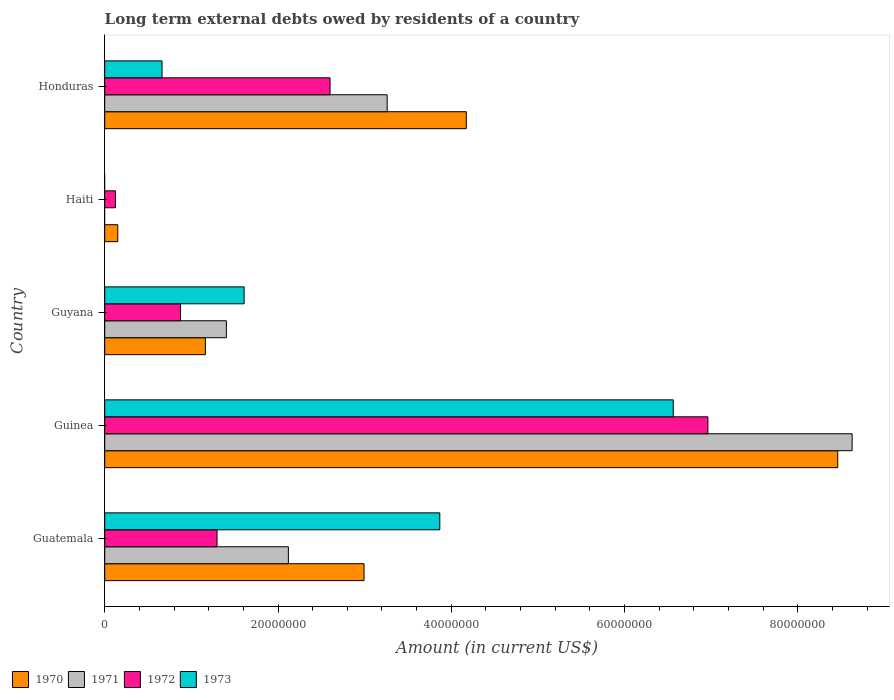How many different coloured bars are there?
Provide a succinct answer. 4. Are the number of bars on each tick of the Y-axis equal?
Your response must be concise. No. What is the label of the 1st group of bars from the top?
Your response must be concise. Honduras. Across all countries, what is the maximum amount of long-term external debts owed by residents in 1971?
Your response must be concise. 8.63e+07. Across all countries, what is the minimum amount of long-term external debts owed by residents in 1972?
Provide a short and direct response. 1.24e+06. In which country was the amount of long-term external debts owed by residents in 1972 maximum?
Offer a very short reply. Guinea. What is the total amount of long-term external debts owed by residents in 1970 in the graph?
Give a very brief answer. 1.69e+08. What is the difference between the amount of long-term external debts owed by residents in 1973 in Guatemala and that in Guyana?
Ensure brevity in your answer.  2.26e+07. What is the difference between the amount of long-term external debts owed by residents in 1970 in Guatemala and the amount of long-term external debts owed by residents in 1973 in Honduras?
Make the answer very short. 2.33e+07. What is the average amount of long-term external debts owed by residents in 1971 per country?
Offer a terse response. 3.08e+07. What is the difference between the amount of long-term external debts owed by residents in 1973 and amount of long-term external debts owed by residents in 1970 in Guatemala?
Offer a very short reply. 8.74e+06. What is the ratio of the amount of long-term external debts owed by residents in 1970 in Guatemala to that in Guyana?
Give a very brief answer. 2.58. Is the amount of long-term external debts owed by residents in 1972 in Haiti less than that in Honduras?
Your response must be concise. Yes. Is the difference between the amount of long-term external debts owed by residents in 1973 in Guatemala and Honduras greater than the difference between the amount of long-term external debts owed by residents in 1970 in Guatemala and Honduras?
Offer a very short reply. Yes. What is the difference between the highest and the second highest amount of long-term external debts owed by residents in 1970?
Provide a succinct answer. 4.29e+07. What is the difference between the highest and the lowest amount of long-term external debts owed by residents in 1972?
Your answer should be compact. 6.84e+07. In how many countries, is the amount of long-term external debts owed by residents in 1970 greater than the average amount of long-term external debts owed by residents in 1970 taken over all countries?
Keep it short and to the point. 2. Is it the case that in every country, the sum of the amount of long-term external debts owed by residents in 1973 and amount of long-term external debts owed by residents in 1970 is greater than the amount of long-term external debts owed by residents in 1971?
Make the answer very short. Yes. How many countries are there in the graph?
Offer a very short reply. 5. What is the difference between two consecutive major ticks on the X-axis?
Keep it short and to the point. 2.00e+07. Does the graph contain any zero values?
Offer a very short reply. Yes. How many legend labels are there?
Make the answer very short. 4. What is the title of the graph?
Keep it short and to the point. Long term external debts owed by residents of a country. Does "1991" appear as one of the legend labels in the graph?
Your answer should be compact. No. What is the label or title of the Y-axis?
Your answer should be compact. Country. What is the Amount (in current US$) in 1970 in Guatemala?
Your answer should be compact. 2.99e+07. What is the Amount (in current US$) in 1971 in Guatemala?
Make the answer very short. 2.12e+07. What is the Amount (in current US$) of 1972 in Guatemala?
Provide a short and direct response. 1.30e+07. What is the Amount (in current US$) in 1973 in Guatemala?
Your response must be concise. 3.87e+07. What is the Amount (in current US$) in 1970 in Guinea?
Your answer should be very brief. 8.46e+07. What is the Amount (in current US$) of 1971 in Guinea?
Your answer should be very brief. 8.63e+07. What is the Amount (in current US$) of 1972 in Guinea?
Offer a terse response. 6.96e+07. What is the Amount (in current US$) of 1973 in Guinea?
Provide a short and direct response. 6.56e+07. What is the Amount (in current US$) in 1970 in Guyana?
Your response must be concise. 1.16e+07. What is the Amount (in current US$) of 1971 in Guyana?
Make the answer very short. 1.40e+07. What is the Amount (in current US$) in 1972 in Guyana?
Provide a short and direct response. 8.75e+06. What is the Amount (in current US$) in 1973 in Guyana?
Provide a succinct answer. 1.61e+07. What is the Amount (in current US$) of 1970 in Haiti?
Give a very brief answer. 1.51e+06. What is the Amount (in current US$) of 1972 in Haiti?
Give a very brief answer. 1.24e+06. What is the Amount (in current US$) in 1973 in Haiti?
Your answer should be compact. 0. What is the Amount (in current US$) in 1970 in Honduras?
Your answer should be very brief. 4.17e+07. What is the Amount (in current US$) in 1971 in Honduras?
Provide a succinct answer. 3.26e+07. What is the Amount (in current US$) of 1972 in Honduras?
Offer a terse response. 2.60e+07. What is the Amount (in current US$) in 1973 in Honduras?
Your answer should be very brief. 6.62e+06. Across all countries, what is the maximum Amount (in current US$) in 1970?
Give a very brief answer. 8.46e+07. Across all countries, what is the maximum Amount (in current US$) of 1971?
Make the answer very short. 8.63e+07. Across all countries, what is the maximum Amount (in current US$) of 1972?
Give a very brief answer. 6.96e+07. Across all countries, what is the maximum Amount (in current US$) of 1973?
Provide a succinct answer. 6.56e+07. Across all countries, what is the minimum Amount (in current US$) in 1970?
Provide a succinct answer. 1.51e+06. Across all countries, what is the minimum Amount (in current US$) of 1972?
Keep it short and to the point. 1.24e+06. What is the total Amount (in current US$) in 1970 in the graph?
Your response must be concise. 1.69e+08. What is the total Amount (in current US$) of 1971 in the graph?
Keep it short and to the point. 1.54e+08. What is the total Amount (in current US$) of 1972 in the graph?
Provide a short and direct response. 1.19e+08. What is the total Amount (in current US$) in 1973 in the graph?
Your answer should be very brief. 1.27e+08. What is the difference between the Amount (in current US$) in 1970 in Guatemala and that in Guinea?
Your response must be concise. -5.47e+07. What is the difference between the Amount (in current US$) in 1971 in Guatemala and that in Guinea?
Provide a short and direct response. -6.51e+07. What is the difference between the Amount (in current US$) of 1972 in Guatemala and that in Guinea?
Your answer should be compact. -5.67e+07. What is the difference between the Amount (in current US$) of 1973 in Guatemala and that in Guinea?
Your response must be concise. -2.69e+07. What is the difference between the Amount (in current US$) in 1970 in Guatemala and that in Guyana?
Offer a terse response. 1.83e+07. What is the difference between the Amount (in current US$) of 1971 in Guatemala and that in Guyana?
Give a very brief answer. 7.16e+06. What is the difference between the Amount (in current US$) of 1972 in Guatemala and that in Guyana?
Offer a terse response. 4.21e+06. What is the difference between the Amount (in current US$) in 1973 in Guatemala and that in Guyana?
Provide a short and direct response. 2.26e+07. What is the difference between the Amount (in current US$) of 1970 in Guatemala and that in Haiti?
Provide a short and direct response. 2.84e+07. What is the difference between the Amount (in current US$) in 1972 in Guatemala and that in Haiti?
Your answer should be compact. 1.17e+07. What is the difference between the Amount (in current US$) in 1970 in Guatemala and that in Honduras?
Make the answer very short. -1.18e+07. What is the difference between the Amount (in current US$) in 1971 in Guatemala and that in Honduras?
Your answer should be compact. -1.14e+07. What is the difference between the Amount (in current US$) of 1972 in Guatemala and that in Honduras?
Give a very brief answer. -1.30e+07. What is the difference between the Amount (in current US$) of 1973 in Guatemala and that in Honduras?
Offer a terse response. 3.21e+07. What is the difference between the Amount (in current US$) in 1970 in Guinea and that in Guyana?
Keep it short and to the point. 7.30e+07. What is the difference between the Amount (in current US$) of 1971 in Guinea and that in Guyana?
Offer a very short reply. 7.22e+07. What is the difference between the Amount (in current US$) of 1972 in Guinea and that in Guyana?
Provide a short and direct response. 6.09e+07. What is the difference between the Amount (in current US$) of 1973 in Guinea and that in Guyana?
Offer a very short reply. 4.95e+07. What is the difference between the Amount (in current US$) of 1970 in Guinea and that in Haiti?
Your answer should be compact. 8.31e+07. What is the difference between the Amount (in current US$) of 1972 in Guinea and that in Haiti?
Ensure brevity in your answer.  6.84e+07. What is the difference between the Amount (in current US$) of 1970 in Guinea and that in Honduras?
Your answer should be compact. 4.29e+07. What is the difference between the Amount (in current US$) of 1971 in Guinea and that in Honduras?
Provide a succinct answer. 5.37e+07. What is the difference between the Amount (in current US$) of 1972 in Guinea and that in Honduras?
Make the answer very short. 4.36e+07. What is the difference between the Amount (in current US$) in 1973 in Guinea and that in Honduras?
Give a very brief answer. 5.90e+07. What is the difference between the Amount (in current US$) in 1970 in Guyana and that in Haiti?
Ensure brevity in your answer.  1.01e+07. What is the difference between the Amount (in current US$) of 1972 in Guyana and that in Haiti?
Offer a very short reply. 7.52e+06. What is the difference between the Amount (in current US$) of 1970 in Guyana and that in Honduras?
Your answer should be very brief. -3.01e+07. What is the difference between the Amount (in current US$) in 1971 in Guyana and that in Honduras?
Give a very brief answer. -1.86e+07. What is the difference between the Amount (in current US$) in 1972 in Guyana and that in Honduras?
Keep it short and to the point. -1.73e+07. What is the difference between the Amount (in current US$) in 1973 in Guyana and that in Honduras?
Your response must be concise. 9.47e+06. What is the difference between the Amount (in current US$) of 1970 in Haiti and that in Honduras?
Give a very brief answer. -4.02e+07. What is the difference between the Amount (in current US$) of 1972 in Haiti and that in Honduras?
Ensure brevity in your answer.  -2.48e+07. What is the difference between the Amount (in current US$) in 1970 in Guatemala and the Amount (in current US$) in 1971 in Guinea?
Keep it short and to the point. -5.63e+07. What is the difference between the Amount (in current US$) of 1970 in Guatemala and the Amount (in current US$) of 1972 in Guinea?
Provide a short and direct response. -3.97e+07. What is the difference between the Amount (in current US$) in 1970 in Guatemala and the Amount (in current US$) in 1973 in Guinea?
Provide a short and direct response. -3.57e+07. What is the difference between the Amount (in current US$) of 1971 in Guatemala and the Amount (in current US$) of 1972 in Guinea?
Make the answer very short. -4.84e+07. What is the difference between the Amount (in current US$) of 1971 in Guatemala and the Amount (in current US$) of 1973 in Guinea?
Keep it short and to the point. -4.44e+07. What is the difference between the Amount (in current US$) in 1972 in Guatemala and the Amount (in current US$) in 1973 in Guinea?
Make the answer very short. -5.27e+07. What is the difference between the Amount (in current US$) of 1970 in Guatemala and the Amount (in current US$) of 1971 in Guyana?
Offer a terse response. 1.59e+07. What is the difference between the Amount (in current US$) of 1970 in Guatemala and the Amount (in current US$) of 1972 in Guyana?
Offer a terse response. 2.12e+07. What is the difference between the Amount (in current US$) of 1970 in Guatemala and the Amount (in current US$) of 1973 in Guyana?
Make the answer very short. 1.38e+07. What is the difference between the Amount (in current US$) in 1971 in Guatemala and the Amount (in current US$) in 1972 in Guyana?
Offer a terse response. 1.24e+07. What is the difference between the Amount (in current US$) of 1971 in Guatemala and the Amount (in current US$) of 1973 in Guyana?
Provide a succinct answer. 5.11e+06. What is the difference between the Amount (in current US$) of 1972 in Guatemala and the Amount (in current US$) of 1973 in Guyana?
Ensure brevity in your answer.  -3.12e+06. What is the difference between the Amount (in current US$) of 1970 in Guatemala and the Amount (in current US$) of 1972 in Haiti?
Keep it short and to the point. 2.87e+07. What is the difference between the Amount (in current US$) in 1971 in Guatemala and the Amount (in current US$) in 1972 in Haiti?
Provide a short and direct response. 2.00e+07. What is the difference between the Amount (in current US$) of 1970 in Guatemala and the Amount (in current US$) of 1971 in Honduras?
Provide a short and direct response. -2.67e+06. What is the difference between the Amount (in current US$) in 1970 in Guatemala and the Amount (in current US$) in 1972 in Honduras?
Give a very brief answer. 3.92e+06. What is the difference between the Amount (in current US$) of 1970 in Guatemala and the Amount (in current US$) of 1973 in Honduras?
Provide a short and direct response. 2.33e+07. What is the difference between the Amount (in current US$) of 1971 in Guatemala and the Amount (in current US$) of 1972 in Honduras?
Give a very brief answer. -4.81e+06. What is the difference between the Amount (in current US$) of 1971 in Guatemala and the Amount (in current US$) of 1973 in Honduras?
Keep it short and to the point. 1.46e+07. What is the difference between the Amount (in current US$) of 1972 in Guatemala and the Amount (in current US$) of 1973 in Honduras?
Your answer should be compact. 6.35e+06. What is the difference between the Amount (in current US$) of 1970 in Guinea and the Amount (in current US$) of 1971 in Guyana?
Offer a very short reply. 7.06e+07. What is the difference between the Amount (in current US$) in 1970 in Guinea and the Amount (in current US$) in 1972 in Guyana?
Offer a terse response. 7.58e+07. What is the difference between the Amount (in current US$) of 1970 in Guinea and the Amount (in current US$) of 1973 in Guyana?
Ensure brevity in your answer.  6.85e+07. What is the difference between the Amount (in current US$) of 1971 in Guinea and the Amount (in current US$) of 1972 in Guyana?
Your answer should be very brief. 7.75e+07. What is the difference between the Amount (in current US$) of 1971 in Guinea and the Amount (in current US$) of 1973 in Guyana?
Make the answer very short. 7.02e+07. What is the difference between the Amount (in current US$) of 1972 in Guinea and the Amount (in current US$) of 1973 in Guyana?
Keep it short and to the point. 5.35e+07. What is the difference between the Amount (in current US$) of 1970 in Guinea and the Amount (in current US$) of 1972 in Haiti?
Offer a terse response. 8.34e+07. What is the difference between the Amount (in current US$) in 1971 in Guinea and the Amount (in current US$) in 1972 in Haiti?
Provide a short and direct response. 8.50e+07. What is the difference between the Amount (in current US$) in 1970 in Guinea and the Amount (in current US$) in 1971 in Honduras?
Keep it short and to the point. 5.20e+07. What is the difference between the Amount (in current US$) of 1970 in Guinea and the Amount (in current US$) of 1972 in Honduras?
Keep it short and to the point. 5.86e+07. What is the difference between the Amount (in current US$) in 1970 in Guinea and the Amount (in current US$) in 1973 in Honduras?
Provide a succinct answer. 7.80e+07. What is the difference between the Amount (in current US$) of 1971 in Guinea and the Amount (in current US$) of 1972 in Honduras?
Keep it short and to the point. 6.03e+07. What is the difference between the Amount (in current US$) of 1971 in Guinea and the Amount (in current US$) of 1973 in Honduras?
Keep it short and to the point. 7.96e+07. What is the difference between the Amount (in current US$) in 1972 in Guinea and the Amount (in current US$) in 1973 in Honduras?
Offer a terse response. 6.30e+07. What is the difference between the Amount (in current US$) of 1970 in Guyana and the Amount (in current US$) of 1972 in Haiti?
Provide a succinct answer. 1.04e+07. What is the difference between the Amount (in current US$) of 1971 in Guyana and the Amount (in current US$) of 1972 in Haiti?
Offer a very short reply. 1.28e+07. What is the difference between the Amount (in current US$) in 1970 in Guyana and the Amount (in current US$) in 1971 in Honduras?
Give a very brief answer. -2.10e+07. What is the difference between the Amount (in current US$) in 1970 in Guyana and the Amount (in current US$) in 1972 in Honduras?
Provide a succinct answer. -1.44e+07. What is the difference between the Amount (in current US$) of 1970 in Guyana and the Amount (in current US$) of 1973 in Honduras?
Provide a short and direct response. 5.00e+06. What is the difference between the Amount (in current US$) in 1971 in Guyana and the Amount (in current US$) in 1972 in Honduras?
Keep it short and to the point. -1.20e+07. What is the difference between the Amount (in current US$) in 1971 in Guyana and the Amount (in current US$) in 1973 in Honduras?
Provide a succinct answer. 7.42e+06. What is the difference between the Amount (in current US$) in 1972 in Guyana and the Amount (in current US$) in 1973 in Honduras?
Your answer should be very brief. 2.14e+06. What is the difference between the Amount (in current US$) in 1970 in Haiti and the Amount (in current US$) in 1971 in Honduras?
Offer a very short reply. -3.11e+07. What is the difference between the Amount (in current US$) in 1970 in Haiti and the Amount (in current US$) in 1972 in Honduras?
Offer a very short reply. -2.45e+07. What is the difference between the Amount (in current US$) in 1970 in Haiti and the Amount (in current US$) in 1973 in Honduras?
Provide a succinct answer. -5.11e+06. What is the difference between the Amount (in current US$) of 1972 in Haiti and the Amount (in current US$) of 1973 in Honduras?
Offer a very short reply. -5.38e+06. What is the average Amount (in current US$) in 1970 per country?
Your answer should be very brief. 3.39e+07. What is the average Amount (in current US$) in 1971 per country?
Offer a terse response. 3.08e+07. What is the average Amount (in current US$) of 1972 per country?
Offer a very short reply. 2.37e+07. What is the average Amount (in current US$) in 1973 per country?
Your answer should be compact. 2.54e+07. What is the difference between the Amount (in current US$) in 1970 and Amount (in current US$) in 1971 in Guatemala?
Your answer should be compact. 8.73e+06. What is the difference between the Amount (in current US$) of 1970 and Amount (in current US$) of 1972 in Guatemala?
Keep it short and to the point. 1.70e+07. What is the difference between the Amount (in current US$) in 1970 and Amount (in current US$) in 1973 in Guatemala?
Provide a succinct answer. -8.74e+06. What is the difference between the Amount (in current US$) in 1971 and Amount (in current US$) in 1972 in Guatemala?
Your response must be concise. 8.23e+06. What is the difference between the Amount (in current US$) in 1971 and Amount (in current US$) in 1973 in Guatemala?
Keep it short and to the point. -1.75e+07. What is the difference between the Amount (in current US$) of 1972 and Amount (in current US$) of 1973 in Guatemala?
Make the answer very short. -2.57e+07. What is the difference between the Amount (in current US$) of 1970 and Amount (in current US$) of 1971 in Guinea?
Provide a succinct answer. -1.66e+06. What is the difference between the Amount (in current US$) of 1970 and Amount (in current US$) of 1972 in Guinea?
Ensure brevity in your answer.  1.50e+07. What is the difference between the Amount (in current US$) of 1970 and Amount (in current US$) of 1973 in Guinea?
Offer a terse response. 1.90e+07. What is the difference between the Amount (in current US$) in 1971 and Amount (in current US$) in 1972 in Guinea?
Offer a very short reply. 1.66e+07. What is the difference between the Amount (in current US$) in 1971 and Amount (in current US$) in 1973 in Guinea?
Your answer should be very brief. 2.06e+07. What is the difference between the Amount (in current US$) of 1970 and Amount (in current US$) of 1971 in Guyana?
Provide a short and direct response. -2.42e+06. What is the difference between the Amount (in current US$) of 1970 and Amount (in current US$) of 1972 in Guyana?
Provide a short and direct response. 2.87e+06. What is the difference between the Amount (in current US$) in 1970 and Amount (in current US$) in 1973 in Guyana?
Your answer should be compact. -4.47e+06. What is the difference between the Amount (in current US$) of 1971 and Amount (in current US$) of 1972 in Guyana?
Make the answer very short. 5.29e+06. What is the difference between the Amount (in current US$) of 1971 and Amount (in current US$) of 1973 in Guyana?
Your answer should be very brief. -2.05e+06. What is the difference between the Amount (in current US$) of 1972 and Amount (in current US$) of 1973 in Guyana?
Your answer should be compact. -7.34e+06. What is the difference between the Amount (in current US$) in 1970 and Amount (in current US$) in 1972 in Haiti?
Make the answer very short. 2.72e+05. What is the difference between the Amount (in current US$) of 1970 and Amount (in current US$) of 1971 in Honduras?
Your answer should be very brief. 9.13e+06. What is the difference between the Amount (in current US$) in 1970 and Amount (in current US$) in 1972 in Honduras?
Offer a terse response. 1.57e+07. What is the difference between the Amount (in current US$) of 1970 and Amount (in current US$) of 1973 in Honduras?
Provide a succinct answer. 3.51e+07. What is the difference between the Amount (in current US$) of 1971 and Amount (in current US$) of 1972 in Honduras?
Offer a very short reply. 6.59e+06. What is the difference between the Amount (in current US$) in 1971 and Amount (in current US$) in 1973 in Honduras?
Your answer should be compact. 2.60e+07. What is the difference between the Amount (in current US$) in 1972 and Amount (in current US$) in 1973 in Honduras?
Your answer should be compact. 1.94e+07. What is the ratio of the Amount (in current US$) of 1970 in Guatemala to that in Guinea?
Your answer should be very brief. 0.35. What is the ratio of the Amount (in current US$) of 1971 in Guatemala to that in Guinea?
Offer a very short reply. 0.25. What is the ratio of the Amount (in current US$) in 1972 in Guatemala to that in Guinea?
Your answer should be very brief. 0.19. What is the ratio of the Amount (in current US$) of 1973 in Guatemala to that in Guinea?
Provide a succinct answer. 0.59. What is the ratio of the Amount (in current US$) in 1970 in Guatemala to that in Guyana?
Keep it short and to the point. 2.58. What is the ratio of the Amount (in current US$) in 1971 in Guatemala to that in Guyana?
Your response must be concise. 1.51. What is the ratio of the Amount (in current US$) of 1972 in Guatemala to that in Guyana?
Your answer should be very brief. 1.48. What is the ratio of the Amount (in current US$) of 1973 in Guatemala to that in Guyana?
Give a very brief answer. 2.4. What is the ratio of the Amount (in current US$) in 1970 in Guatemala to that in Haiti?
Provide a short and direct response. 19.86. What is the ratio of the Amount (in current US$) in 1972 in Guatemala to that in Haiti?
Offer a terse response. 10.5. What is the ratio of the Amount (in current US$) of 1970 in Guatemala to that in Honduras?
Make the answer very short. 0.72. What is the ratio of the Amount (in current US$) of 1971 in Guatemala to that in Honduras?
Provide a succinct answer. 0.65. What is the ratio of the Amount (in current US$) in 1972 in Guatemala to that in Honduras?
Provide a succinct answer. 0.5. What is the ratio of the Amount (in current US$) of 1973 in Guatemala to that in Honduras?
Keep it short and to the point. 5.85. What is the ratio of the Amount (in current US$) of 1970 in Guinea to that in Guyana?
Provide a short and direct response. 7.28. What is the ratio of the Amount (in current US$) of 1971 in Guinea to that in Guyana?
Ensure brevity in your answer.  6.14. What is the ratio of the Amount (in current US$) in 1972 in Guinea to that in Guyana?
Your response must be concise. 7.96. What is the ratio of the Amount (in current US$) of 1973 in Guinea to that in Guyana?
Make the answer very short. 4.08. What is the ratio of the Amount (in current US$) in 1970 in Guinea to that in Haiti?
Your response must be concise. 56.14. What is the ratio of the Amount (in current US$) in 1972 in Guinea to that in Haiti?
Your answer should be compact. 56.37. What is the ratio of the Amount (in current US$) in 1970 in Guinea to that in Honduras?
Give a very brief answer. 2.03. What is the ratio of the Amount (in current US$) in 1971 in Guinea to that in Honduras?
Offer a very short reply. 2.65. What is the ratio of the Amount (in current US$) in 1972 in Guinea to that in Honduras?
Give a very brief answer. 2.68. What is the ratio of the Amount (in current US$) in 1973 in Guinea to that in Honduras?
Keep it short and to the point. 9.92. What is the ratio of the Amount (in current US$) in 1970 in Guyana to that in Haiti?
Ensure brevity in your answer.  7.71. What is the ratio of the Amount (in current US$) of 1972 in Guyana to that in Haiti?
Provide a succinct answer. 7.09. What is the ratio of the Amount (in current US$) of 1970 in Guyana to that in Honduras?
Your answer should be compact. 0.28. What is the ratio of the Amount (in current US$) of 1971 in Guyana to that in Honduras?
Your response must be concise. 0.43. What is the ratio of the Amount (in current US$) in 1972 in Guyana to that in Honduras?
Provide a succinct answer. 0.34. What is the ratio of the Amount (in current US$) of 1973 in Guyana to that in Honduras?
Offer a very short reply. 2.43. What is the ratio of the Amount (in current US$) in 1970 in Haiti to that in Honduras?
Keep it short and to the point. 0.04. What is the ratio of the Amount (in current US$) in 1972 in Haiti to that in Honduras?
Your answer should be very brief. 0.05. What is the difference between the highest and the second highest Amount (in current US$) in 1970?
Provide a succinct answer. 4.29e+07. What is the difference between the highest and the second highest Amount (in current US$) of 1971?
Provide a short and direct response. 5.37e+07. What is the difference between the highest and the second highest Amount (in current US$) of 1972?
Your answer should be compact. 4.36e+07. What is the difference between the highest and the second highest Amount (in current US$) of 1973?
Your answer should be compact. 2.69e+07. What is the difference between the highest and the lowest Amount (in current US$) of 1970?
Your response must be concise. 8.31e+07. What is the difference between the highest and the lowest Amount (in current US$) in 1971?
Provide a short and direct response. 8.63e+07. What is the difference between the highest and the lowest Amount (in current US$) of 1972?
Ensure brevity in your answer.  6.84e+07. What is the difference between the highest and the lowest Amount (in current US$) in 1973?
Offer a terse response. 6.56e+07. 